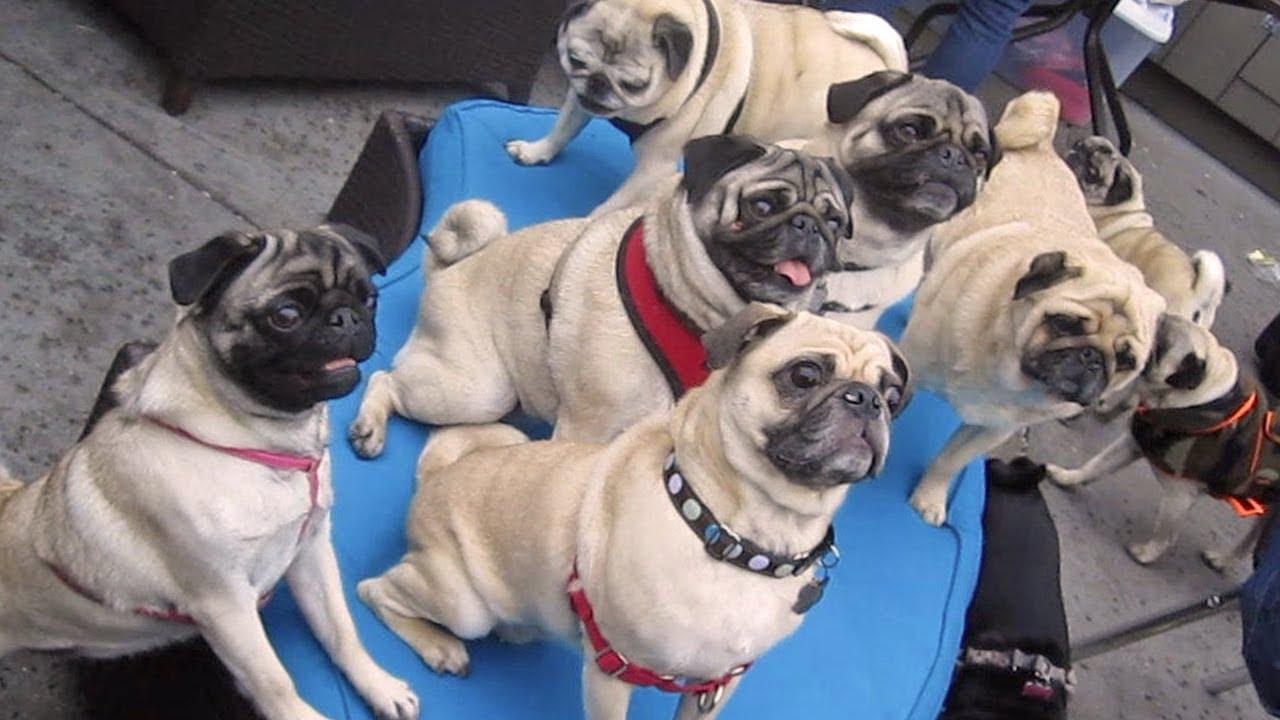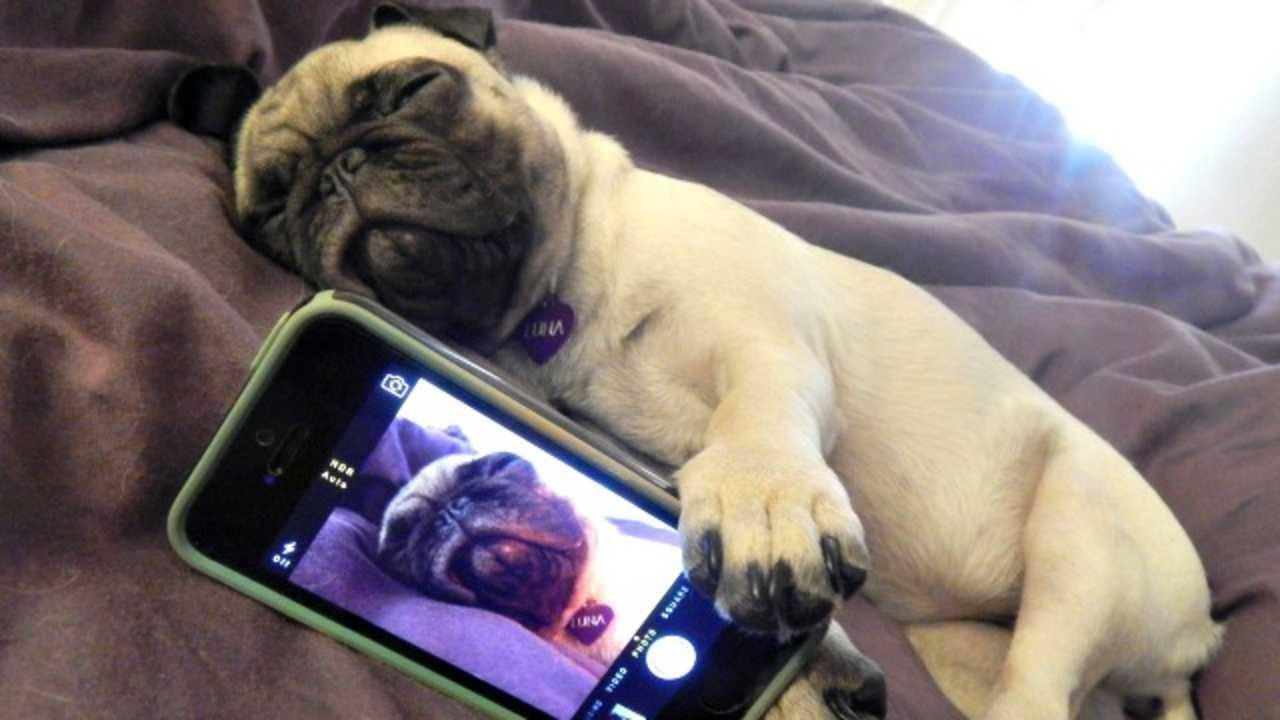The first image is the image on the left, the second image is the image on the right. For the images displayed, is the sentence "there are pugs with harnesses on" factually correct? Answer yes or no. Yes. The first image is the image on the left, the second image is the image on the right. Considering the images on both sides, is "At least one dog is sleeping." valid? Answer yes or no. Yes. 